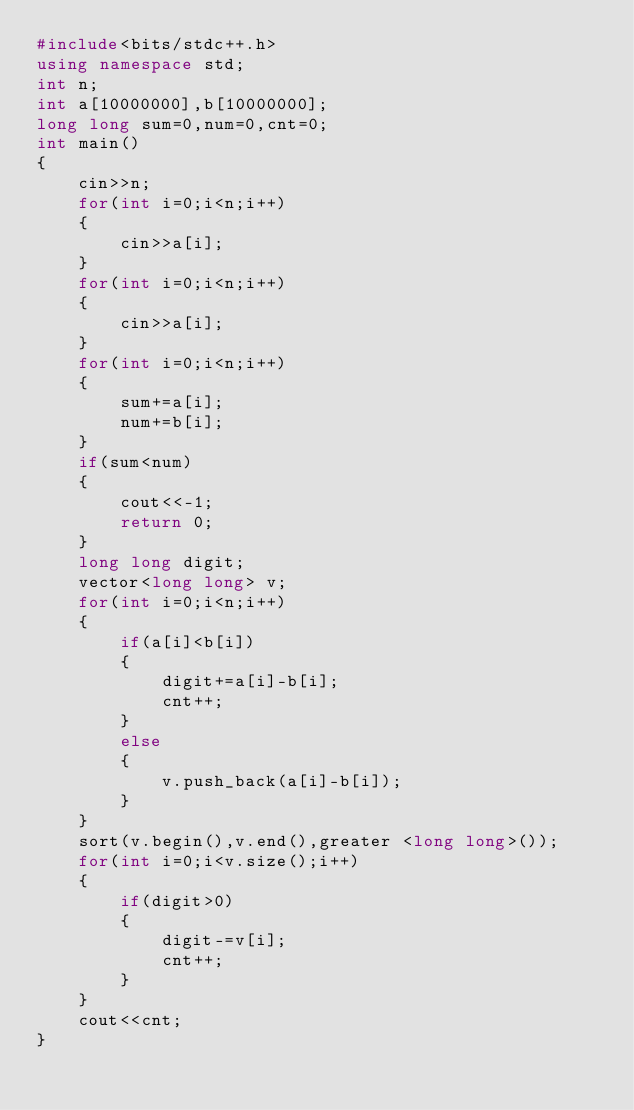<code> <loc_0><loc_0><loc_500><loc_500><_C++_>#include<bits/stdc++.h>
using namespace std;
int n;
int a[10000000],b[10000000];
long long sum=0,num=0,cnt=0;
int main()
{
	cin>>n;
	for(int i=0;i<n;i++)
	{
		cin>>a[i];
	}
	for(int i=0;i<n;i++)
	{
		cin>>a[i];
	}
	for(int i=0;i<n;i++)
	{
		sum+=a[i];
		num+=b[i];
	}
	if(sum<num)
	{
		cout<<-1;
		return 0;
	}
	long long digit;
	vector<long long> v;
	for(int i=0;i<n;i++)
	{
		if(a[i]<b[i])
		{
			digit+=a[i]-b[i];
			cnt++;
		}
		else
		{
			v.push_back(a[i]-b[i]);
		}
	}
	sort(v.begin(),v.end(),greater <long long>());
	for(int i=0;i<v.size();i++)
	{
		if(digit>0)
		{
			digit-=v[i];
			cnt++;
		}
	}
	cout<<cnt;
}</code> 